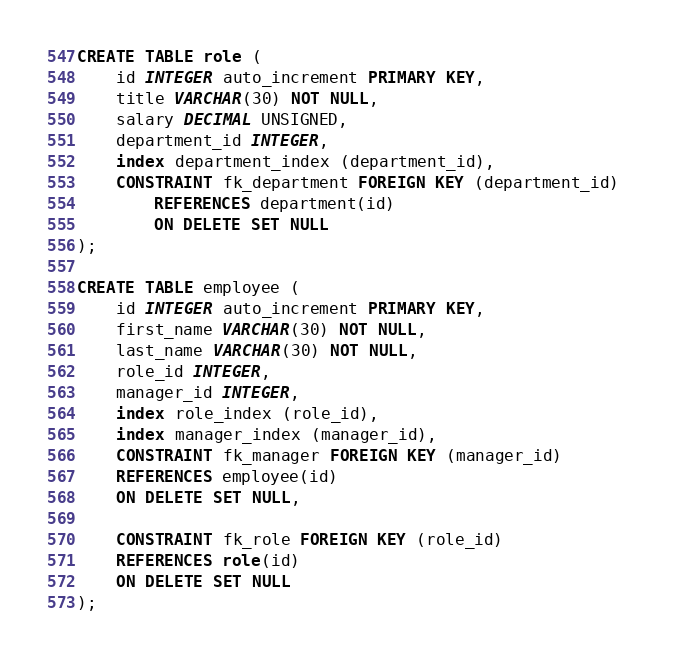Convert code to text. <code><loc_0><loc_0><loc_500><loc_500><_SQL_>
CREATE TABLE role (
    id INTEGER auto_increment PRIMARY KEY,
    title VARCHAR(30) NOT NULL,
    salary DECIMAL UNSIGNED,
    department_id INTEGER,
    index department_index (department_id),
    CONSTRAINT fk_department FOREIGN KEY (department_id) 
        REFERENCES department(id) 
        ON DELETE SET NULL
);

CREATE TABLE employee (
    id INTEGER auto_increment PRIMARY KEY,
    first_name VARCHAR(30) NOT NULL,
    last_name VARCHAR(30) NOT NULL,
    role_id INTEGER,
    manager_id INTEGER,
    index role_index (role_id),
    index manager_index (manager_id),
    CONSTRAINT fk_manager FOREIGN KEY (manager_id) 
    REFERENCES employee(id) 
    ON DELETE SET NULL,
    
    CONSTRAINT fk_role FOREIGN KEY (role_id) 
    REFERENCES role(id) 
    ON DELETE SET NULL
);</code> 